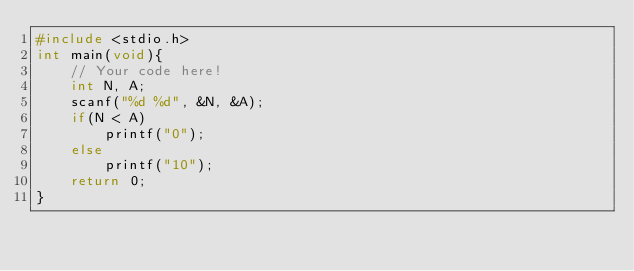<code> <loc_0><loc_0><loc_500><loc_500><_C_>#include <stdio.h>
int main(void){
    // Your code here!
    int N, A;
    scanf("%d %d", &N, &A);
    if(N < A)
        printf("0");
    else
        printf("10");
    return 0;
}
</code> 